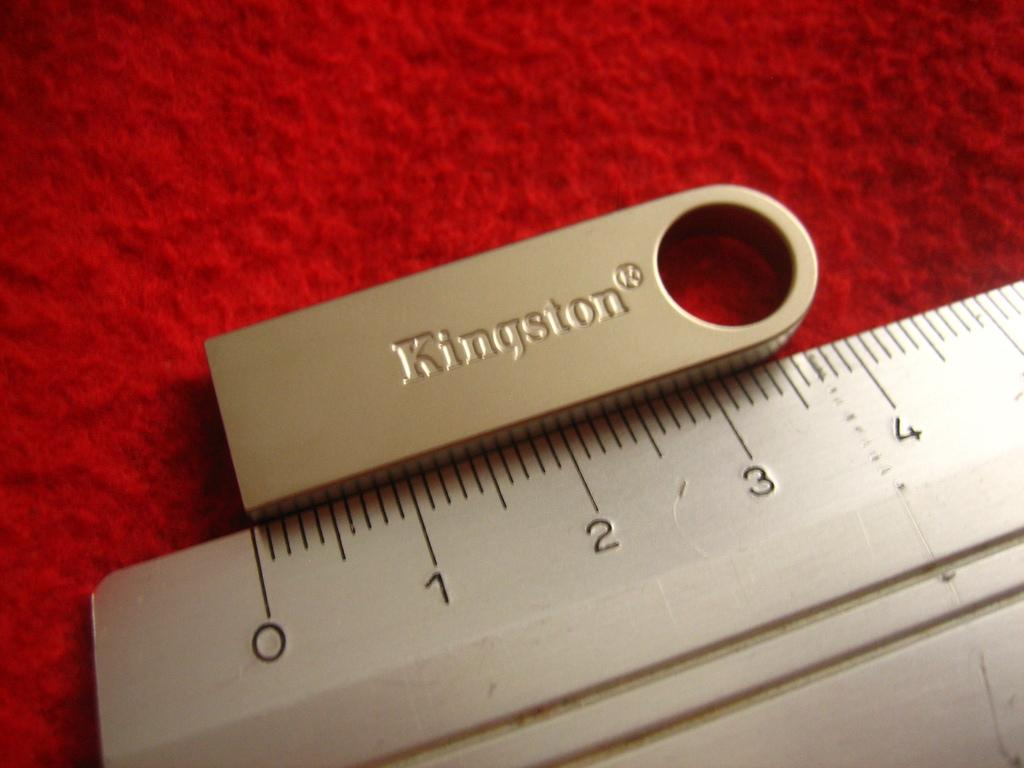What is the main object in the image? There is a measuring scale with lines and numerical numbers in the image. What is the color of the object next to the measuring scale? There is a silver object in the image. What is the color of the surface on which the objects are placed? The objects are placed on a red surface. What type of feather can be seen in the aftermath of the explosion in the image? There is no explosion or feather present in the image. 